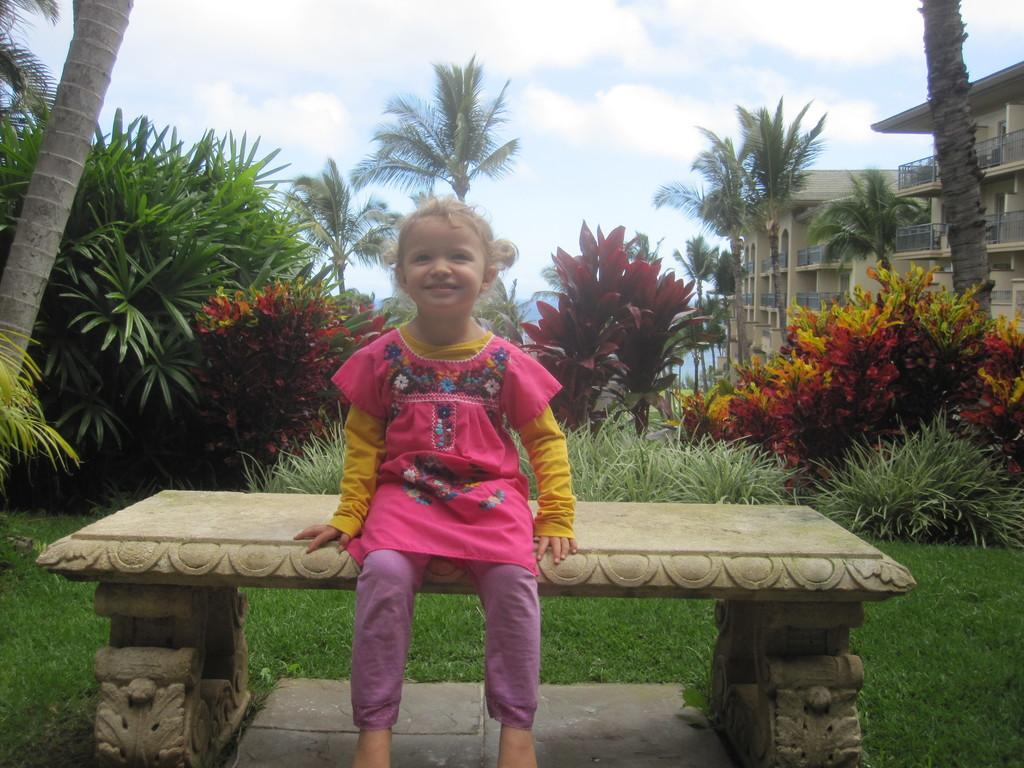What is the girl in the image doing? The girl is sitting on a bench in the image. What is the girl's facial expression? The girl is smiling. What can be seen in the background of the image? There is grass, plants, buildings, trees, railings, and the sky visible in the background of the image. What is the condition of the sky in the image? The sky is visible in the background of the image, and there are clouds present. What type of liquid is being poured onto the sheet in the image? There is no sheet or liquid present in the image. What is the line used for in the image? There is no line present in the image. 